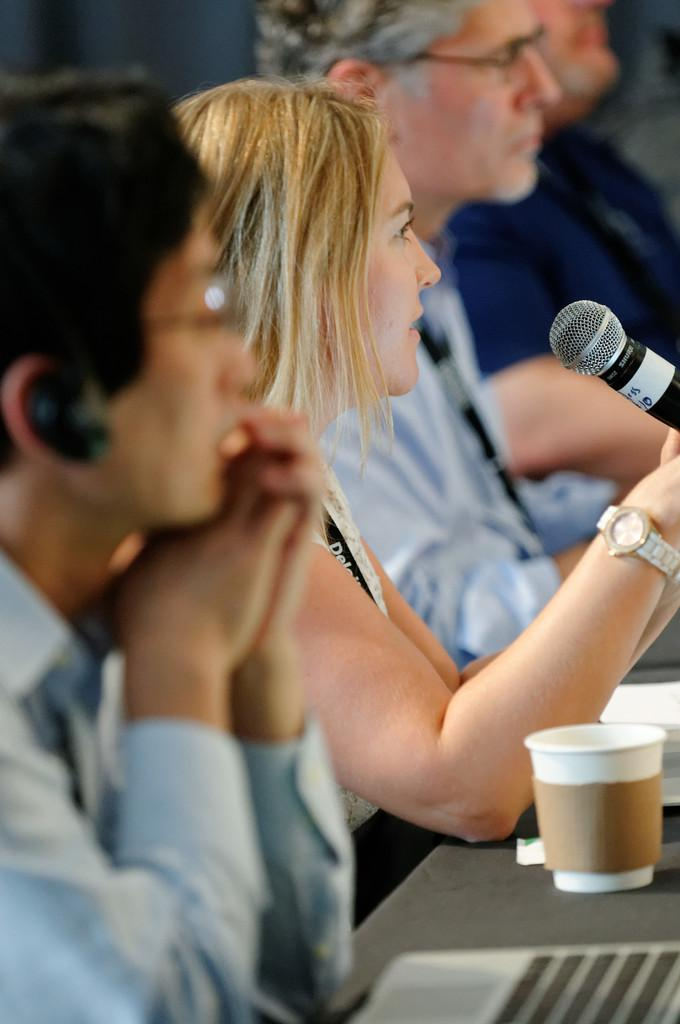How many people are sitting in the image? There are four people sitting in the image. What is present in the image besides the people? There is a table, a glass, papers, a woman holding a mike, and a laptop in the image. What is the woman holding in her hands? The woman is holding a mike in her hands. What device can be seen on the table? There is a laptop on the table in the image. What type of oven is visible in the image? There is no oven present in the image. What message of hope can be seen on the flag in the image? There is no flag present in the image, so no message of hope can be seen. 